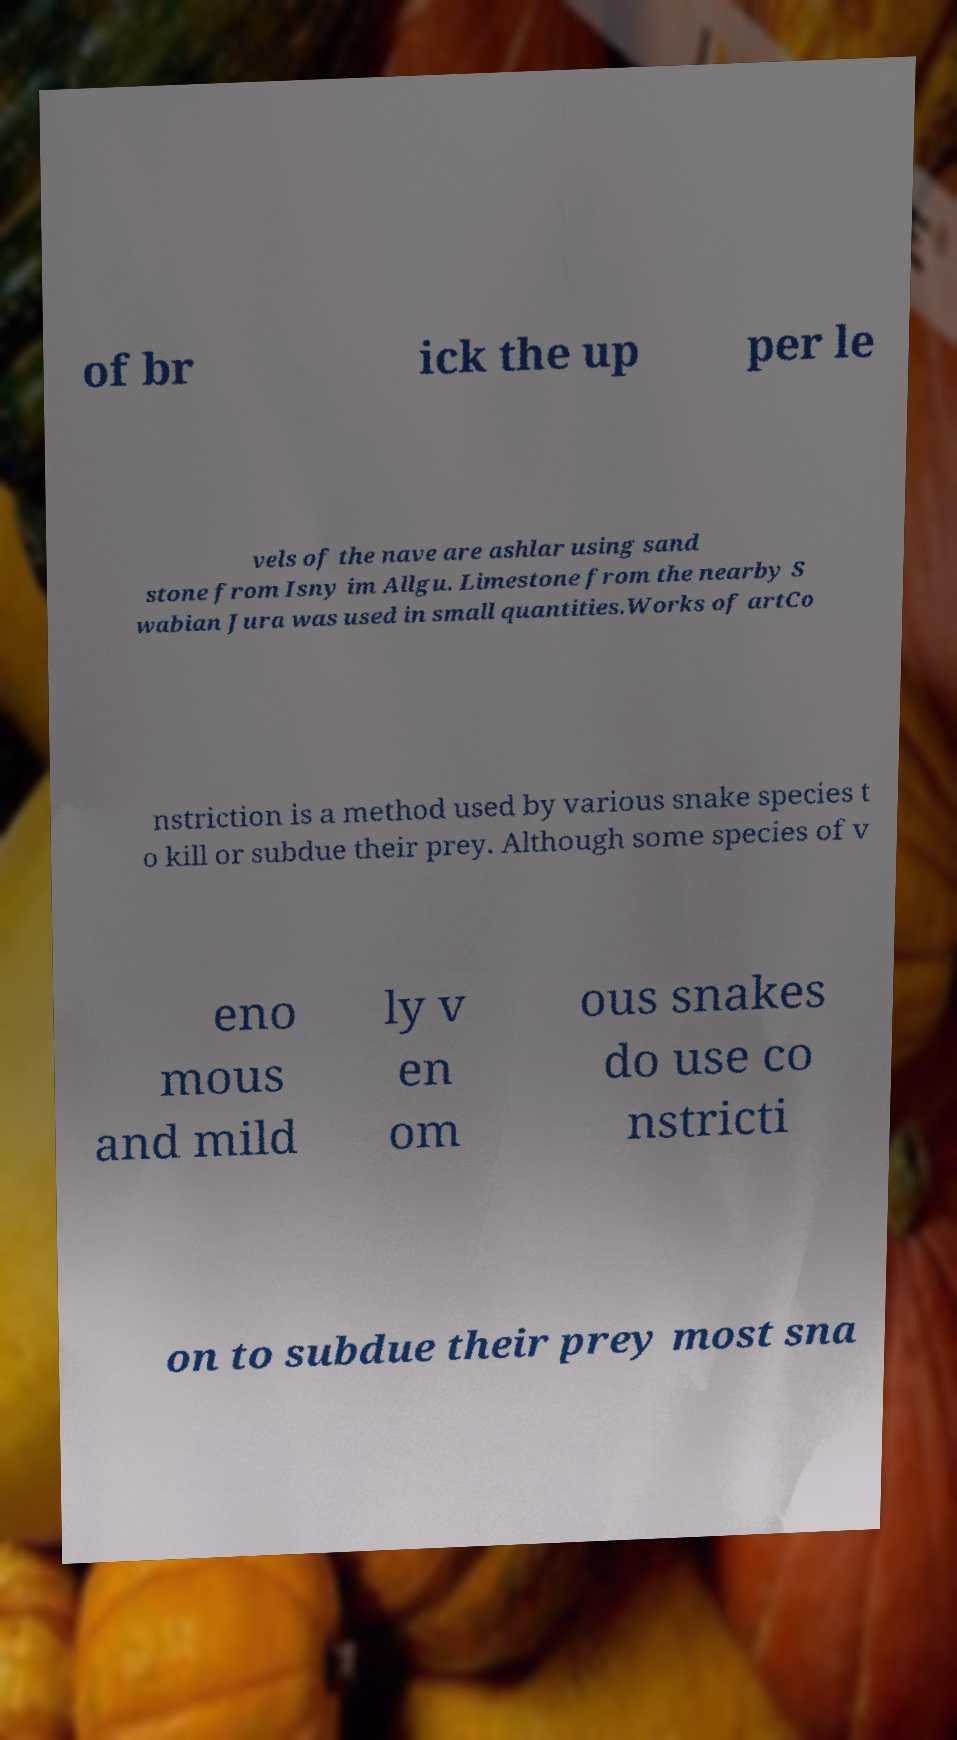For documentation purposes, I need the text within this image transcribed. Could you provide that? of br ick the up per le vels of the nave are ashlar using sand stone from Isny im Allgu. Limestone from the nearby S wabian Jura was used in small quantities.Works of artCo nstriction is a method used by various snake species t o kill or subdue their prey. Although some species of v eno mous and mild ly v en om ous snakes do use co nstricti on to subdue their prey most sna 